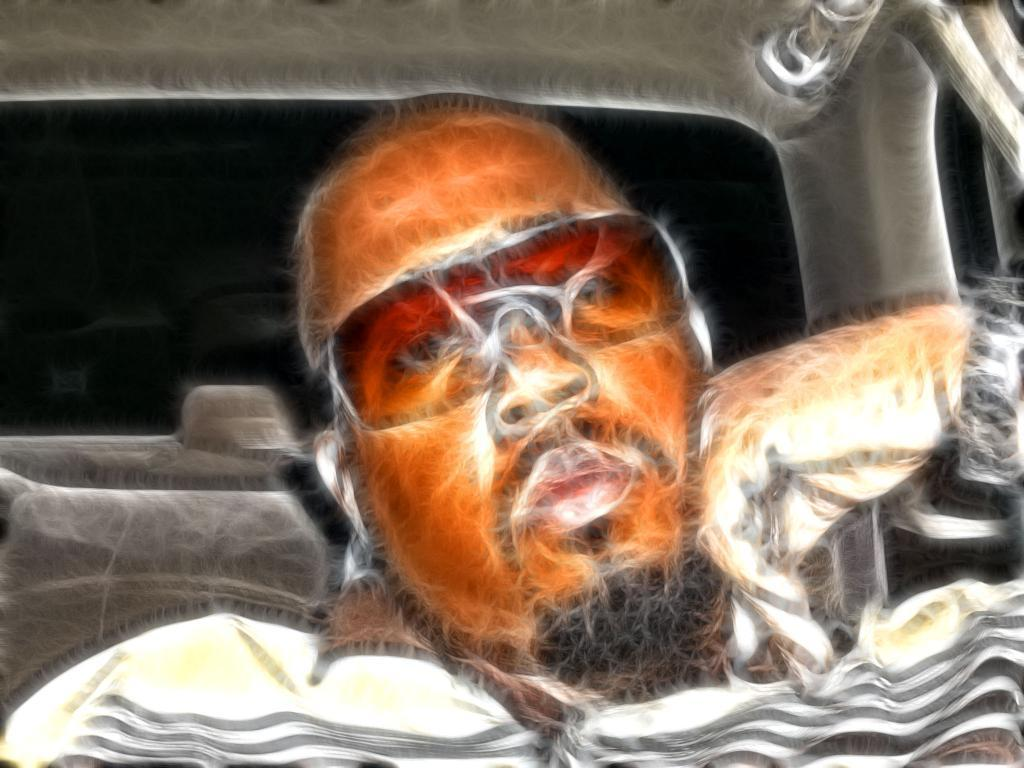What is depicted in the image? There are graphics of a person in the image. What type of cakes are being served at the event in the image? There is no event or cakes present in the image; it only features graphics of a person. Which direction is the person facing in the image? The provided facts do not mention the direction the person is facing, so it cannot be determined from the image. 